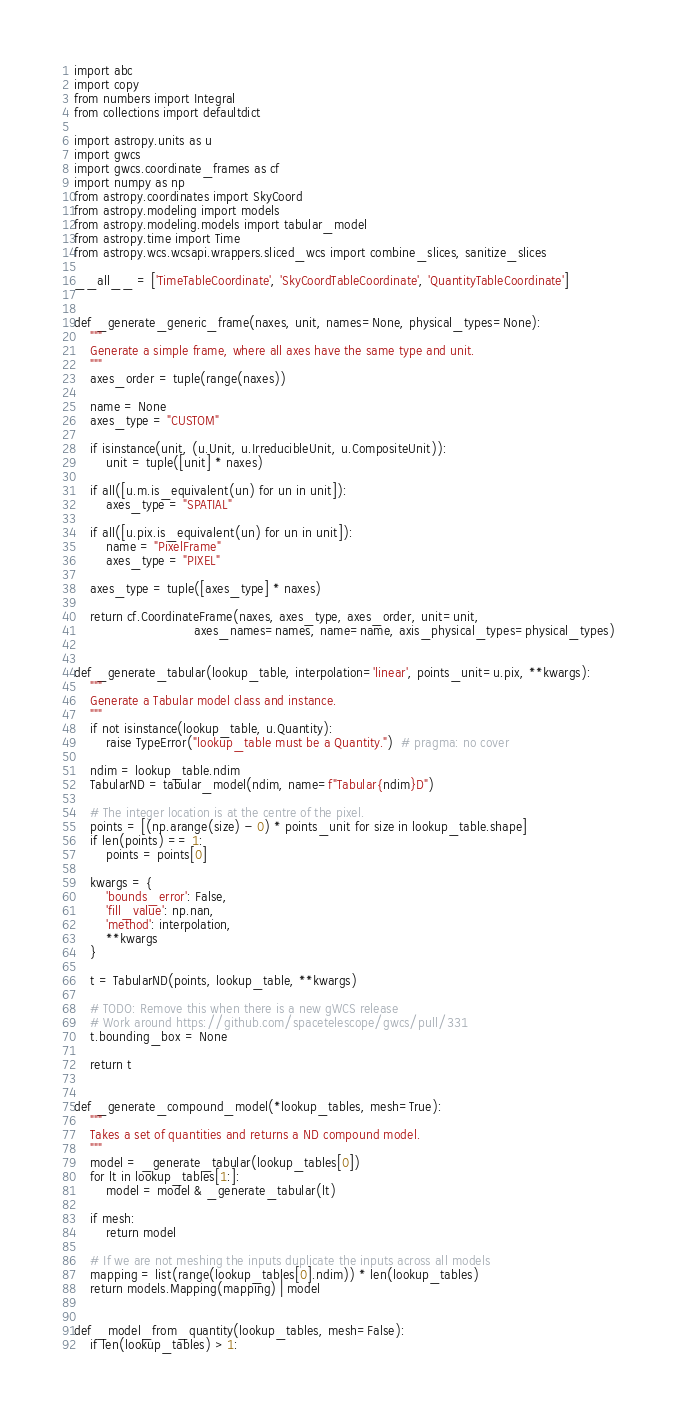<code> <loc_0><loc_0><loc_500><loc_500><_Python_>import abc
import copy
from numbers import Integral
from collections import defaultdict

import astropy.units as u
import gwcs
import gwcs.coordinate_frames as cf
import numpy as np
from astropy.coordinates import SkyCoord
from astropy.modeling import models
from astropy.modeling.models import tabular_model
from astropy.time import Time
from astropy.wcs.wcsapi.wrappers.sliced_wcs import combine_slices, sanitize_slices

__all__ = ['TimeTableCoordinate', 'SkyCoordTableCoordinate', 'QuantityTableCoordinate']


def _generate_generic_frame(naxes, unit, names=None, physical_types=None):
    """
    Generate a simple frame, where all axes have the same type and unit.
    """
    axes_order = tuple(range(naxes))

    name = None
    axes_type = "CUSTOM"

    if isinstance(unit, (u.Unit, u.IrreducibleUnit, u.CompositeUnit)):
        unit = tuple([unit] * naxes)

    if all([u.m.is_equivalent(un) for un in unit]):
        axes_type = "SPATIAL"

    if all([u.pix.is_equivalent(un) for un in unit]):
        name = "PixelFrame"
        axes_type = "PIXEL"

    axes_type = tuple([axes_type] * naxes)

    return cf.CoordinateFrame(naxes, axes_type, axes_order, unit=unit,
                              axes_names=names, name=name, axis_physical_types=physical_types)


def _generate_tabular(lookup_table, interpolation='linear', points_unit=u.pix, **kwargs):
    """
    Generate a Tabular model class and instance.
    """
    if not isinstance(lookup_table, u.Quantity):
        raise TypeError("lookup_table must be a Quantity.")  # pragma: no cover

    ndim = lookup_table.ndim
    TabularND = tabular_model(ndim, name=f"Tabular{ndim}D")

    # The integer location is at the centre of the pixel.
    points = [(np.arange(size) - 0) * points_unit for size in lookup_table.shape]
    if len(points) == 1:
        points = points[0]

    kwargs = {
        'bounds_error': False,
        'fill_value': np.nan,
        'method': interpolation,
        **kwargs
    }

    t = TabularND(points, lookup_table, **kwargs)

    # TODO: Remove this when there is a new gWCS release
    # Work around https://github.com/spacetelescope/gwcs/pull/331
    t.bounding_box = None

    return t


def _generate_compound_model(*lookup_tables, mesh=True):
    """
    Takes a set of quantities and returns a ND compound model.
    """
    model = _generate_tabular(lookup_tables[0])
    for lt in lookup_tables[1:]:
        model = model & _generate_tabular(lt)

    if mesh:
        return model

    # If we are not meshing the inputs duplicate the inputs across all models
    mapping = list(range(lookup_tables[0].ndim)) * len(lookup_tables)
    return models.Mapping(mapping) | model


def _model_from_quantity(lookup_tables, mesh=False):
    if len(lookup_tables) > 1:</code> 